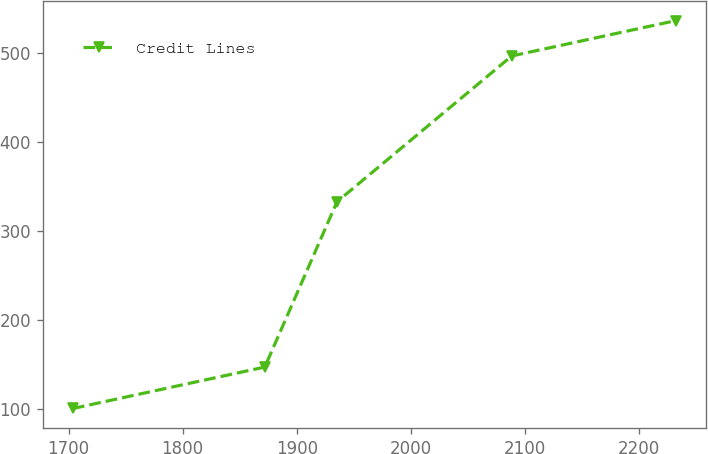Convert chart to OTSL. <chart><loc_0><loc_0><loc_500><loc_500><line_chart><ecel><fcel>Credit Lines<nl><fcel>1703.74<fcel>100.47<nl><fcel>1871.99<fcel>146.97<nl><fcel>1935.3<fcel>332.54<nl><fcel>2088.5<fcel>496.15<nl><fcel>2232.71<fcel>535.93<nl></chart> 